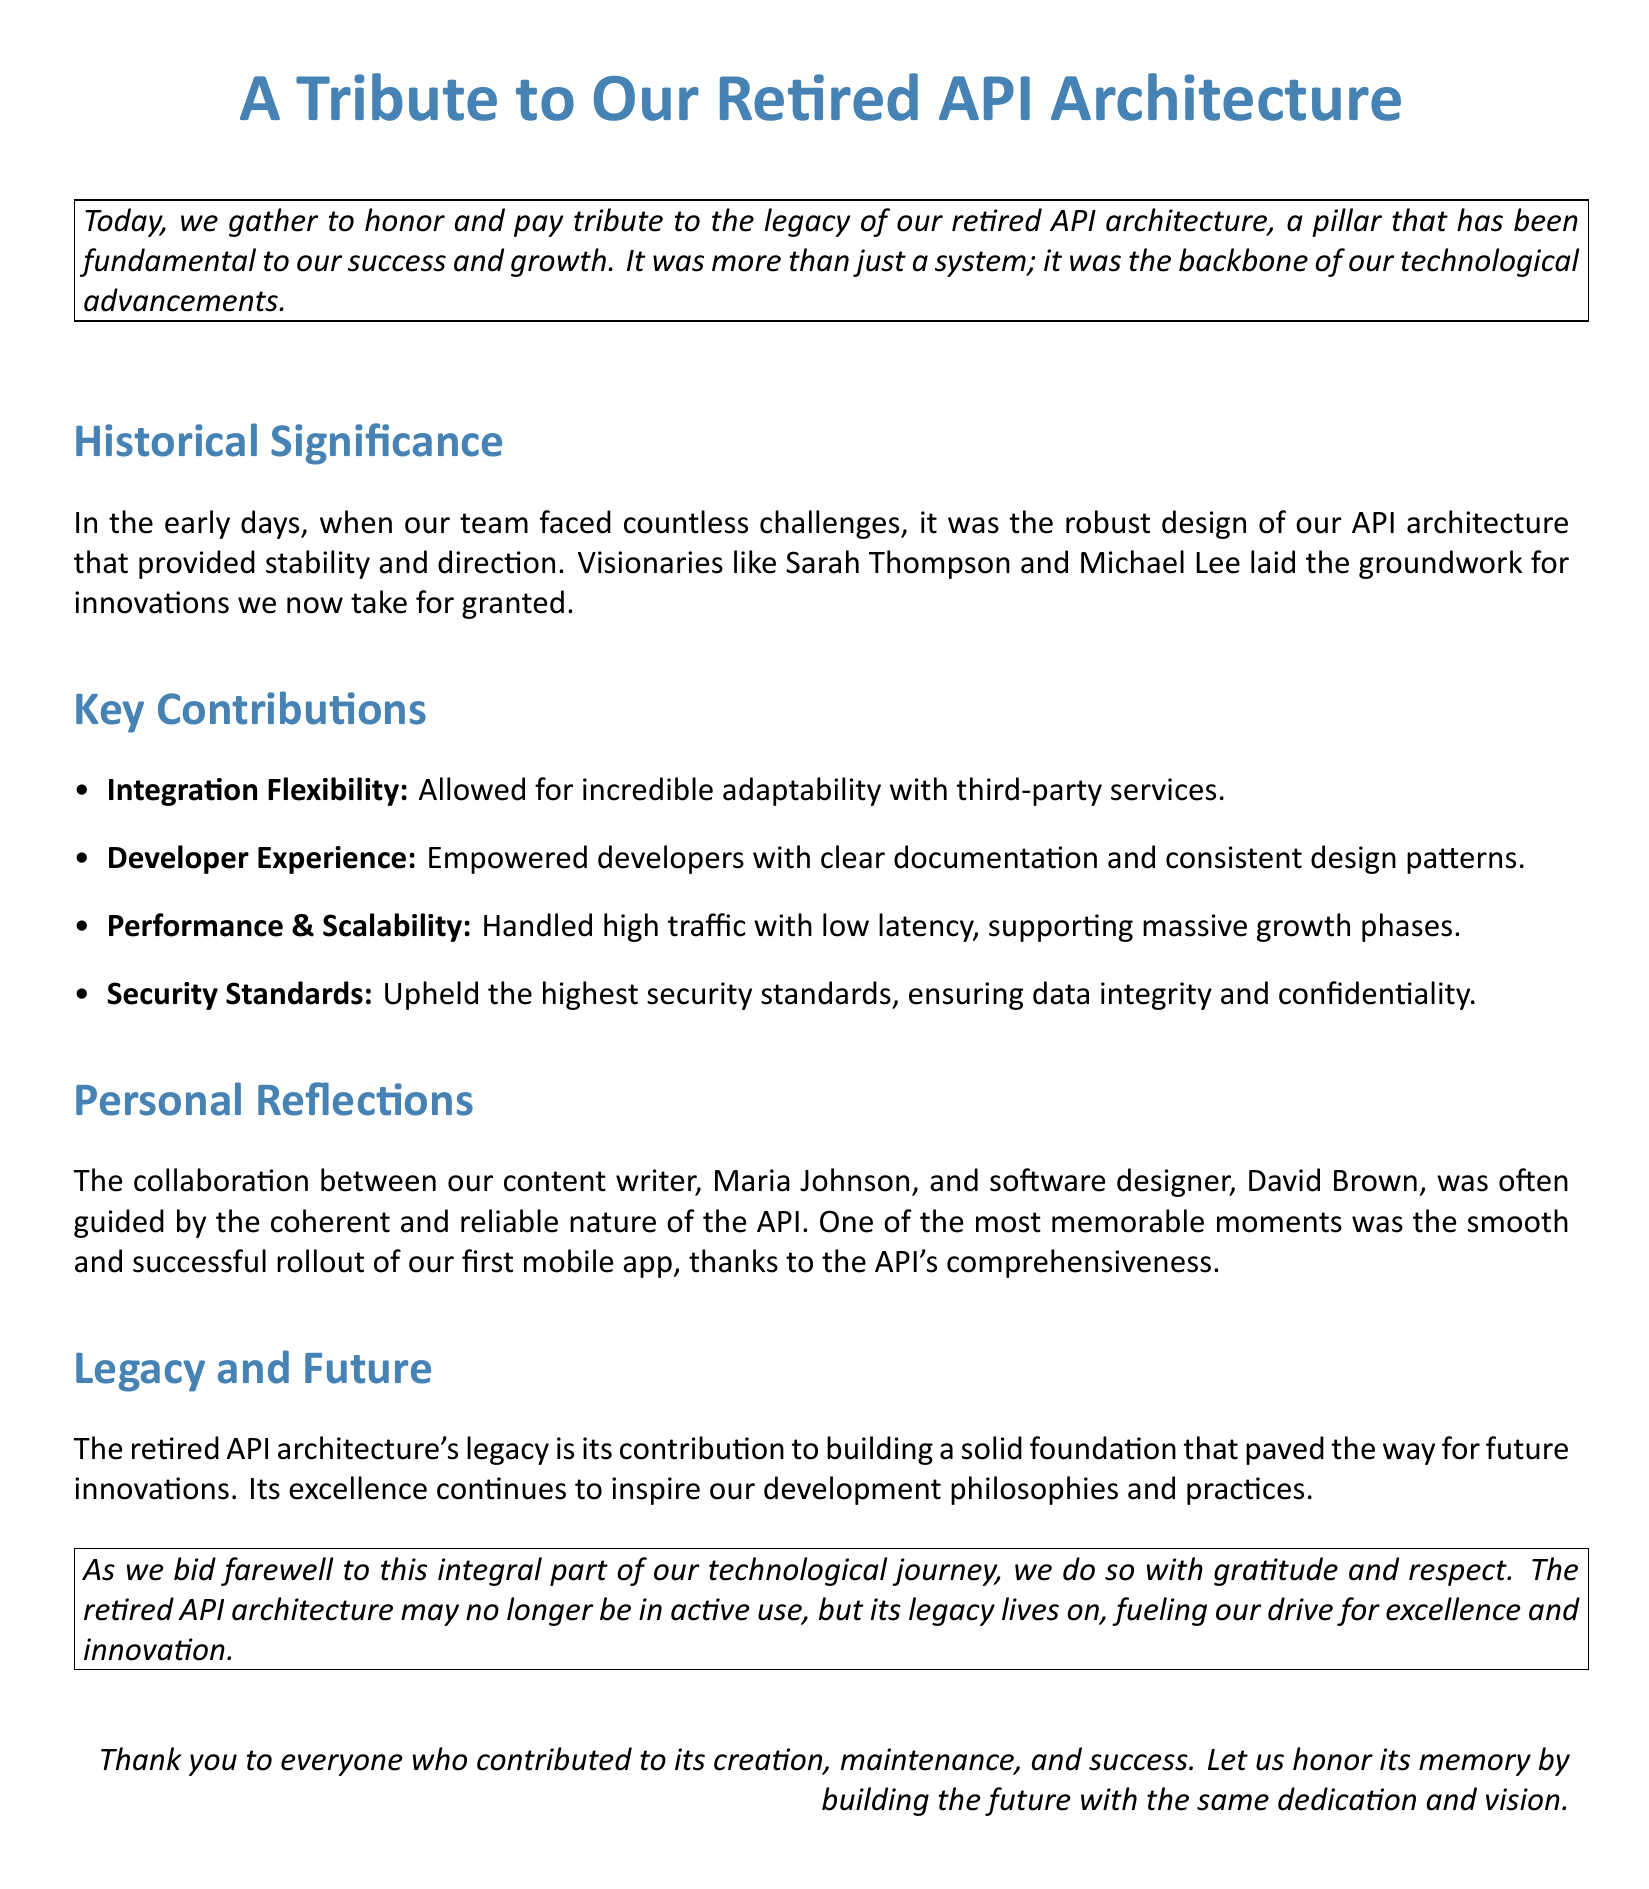What is the title of the document? The title is clearly mentioned at the beginning of the document.
Answer: A Tribute to Our Retired API Architecture Who were the visionaries mentioned in the historical significance section? The document specifically names two individuals instrumental in the API architecture's development.
Answer: Sarah Thompson and Michael Lee What was one of the key contributions related to performance? The document lists several key contributions, one of which relates to performance.
Answer: Performance & Scalability What empowering feature did the API provide to developers? The document highlights how the API impacted developers positively.
Answer: Clear documentation What notable event involved the collaboration between the content writer and software designer? A specific event that is remembered fondly regarding the API's support is detailed in the personal reflections.
Answer: The rollout of our first mobile app What does the document say about the future of the API architecture's legacy? The section on legacy summarizes its ongoing influence on development.
Answer: Building a solid foundation for future innovations What emotion does the document convey toward the retired API architecture? The overall tone of the document reflects a particular sentiment regarding the legacy of the API.
Answer: Gratitude and respect 